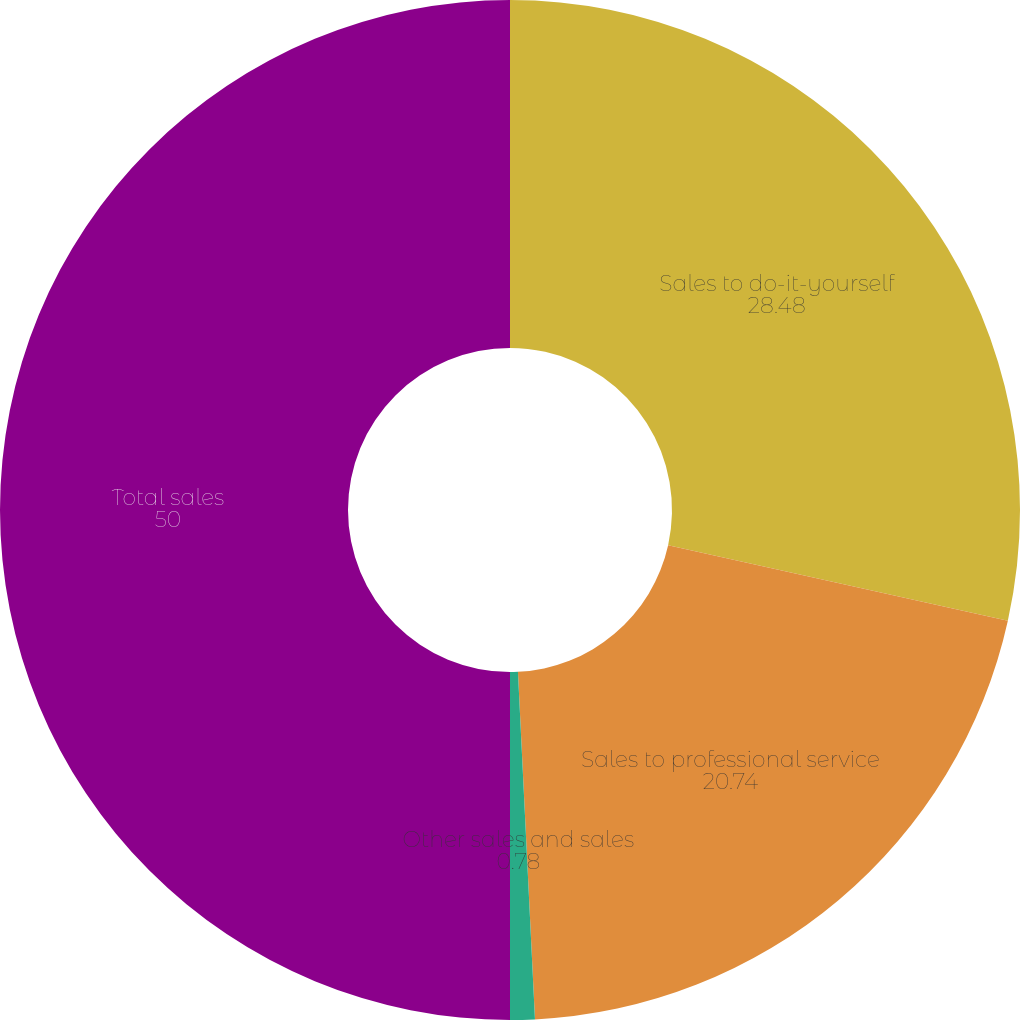<chart> <loc_0><loc_0><loc_500><loc_500><pie_chart><fcel>Sales to do-it-yourself<fcel>Sales to professional service<fcel>Other sales and sales<fcel>Total sales<nl><fcel>28.48%<fcel>20.74%<fcel>0.78%<fcel>50.0%<nl></chart> 